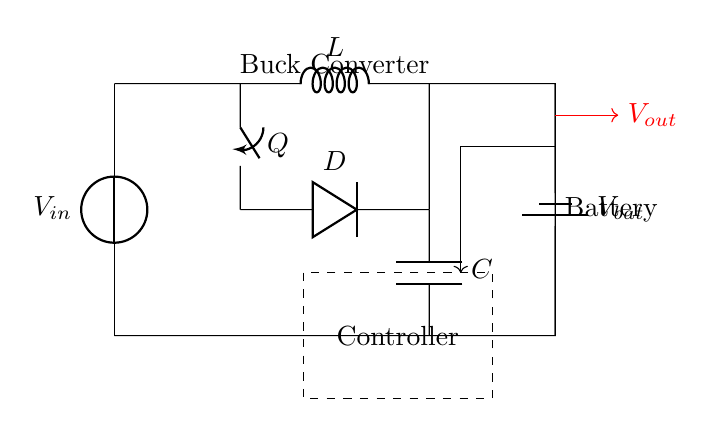What is the input voltage source labeled as? The input voltage source is labeled as V sub in, which stands for the input voltage of the circuit.
Answer: V in What type of component is Q in the circuit? Q is represented as a switch, which is used to control the flow of current in the buck converter.
Answer: Switch What is the purpose of the inductor L in this circuit? The inductor L is used to store energy and smooth the output current in the buck converter operation.
Answer: Energy storage What does the dashed rectangle in the circuit represent? The dashed rectangle encloses the area of the controller, which manages the operation of the buck converter by adjusting the switch Q.
Answer: Controller What is the output voltage denoted by in the diagram? The output voltage is labeled as V sub out, indicating the voltage that will be delivered to the battery or output load.
Answer: V out How does the feedback from the battery connect in the circuit? The feedback is shown as a red arrow, indicating the direction of feedback from the battery to the controller for regulation purposes.
Answer: To the controller What is the purpose of the diode D in this buck converter circuit? The diode D provides a path for current when the switch Q is off, preventing the inductor from discharging back into the circuit and allowing current to flow to the output smoothly.
Answer: Prevents backflow 